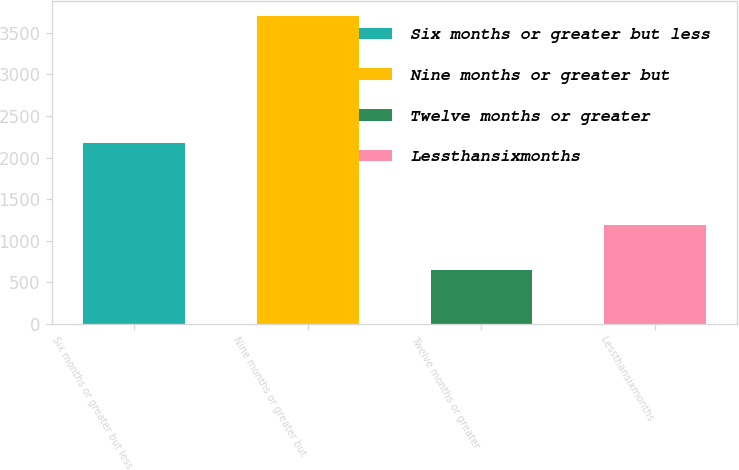Convert chart. <chart><loc_0><loc_0><loc_500><loc_500><bar_chart><fcel>Six months or greater but less<fcel>Nine months or greater but<fcel>Twelve months or greater<fcel>Lessthansixmonths<nl><fcel>2180<fcel>3700<fcel>650<fcel>1190<nl></chart> 